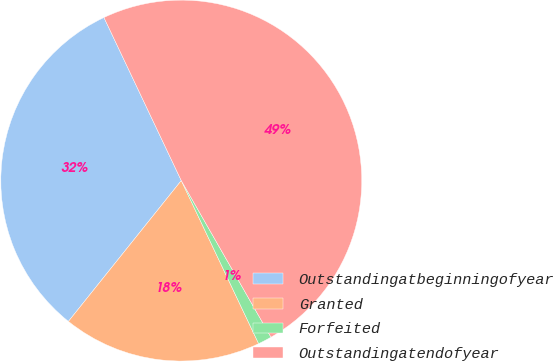<chart> <loc_0><loc_0><loc_500><loc_500><pie_chart><fcel>Outstandingatbeginningofyear<fcel>Granted<fcel>Forfeited<fcel>Outstandingatendofyear<nl><fcel>32.2%<fcel>17.8%<fcel>1.23%<fcel>48.77%<nl></chart> 